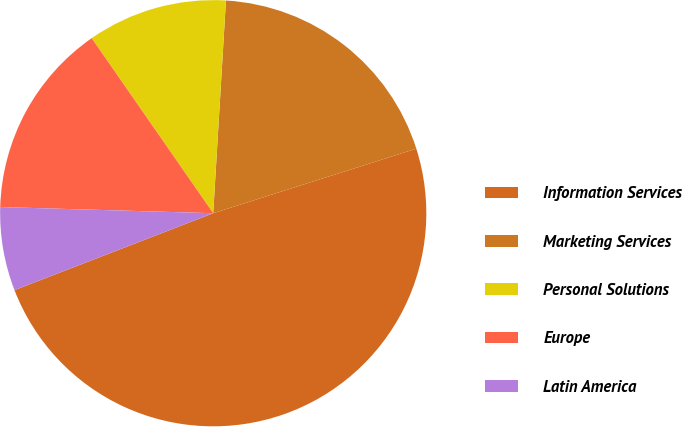<chart> <loc_0><loc_0><loc_500><loc_500><pie_chart><fcel>Information Services<fcel>Marketing Services<fcel>Personal Solutions<fcel>Europe<fcel>Latin America<nl><fcel>49.02%<fcel>19.15%<fcel>10.61%<fcel>14.88%<fcel>6.34%<nl></chart> 